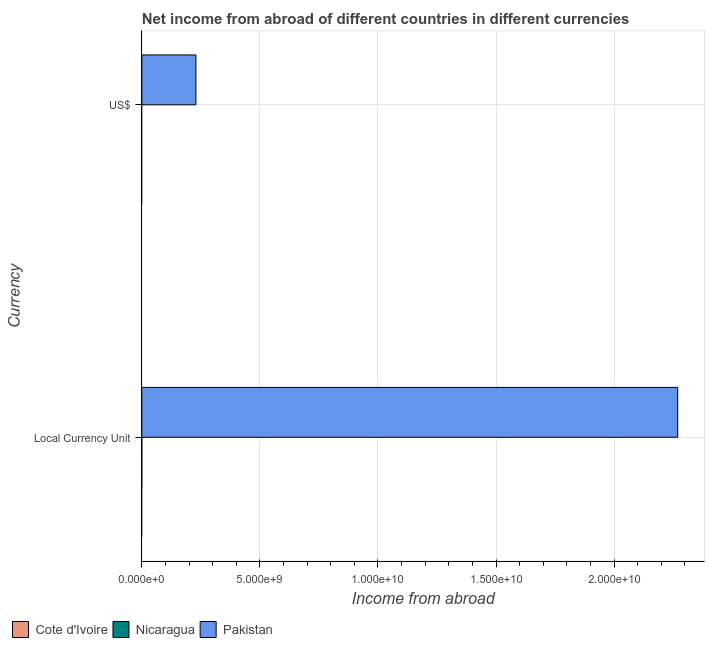Are the number of bars on each tick of the Y-axis equal?
Provide a short and direct response. Yes. How many bars are there on the 2nd tick from the top?
Ensure brevity in your answer.  1. How many bars are there on the 2nd tick from the bottom?
Provide a short and direct response. 1. What is the label of the 1st group of bars from the top?
Your response must be concise. US$. What is the income from abroad in us$ in Nicaragua?
Provide a short and direct response. 0. Across all countries, what is the maximum income from abroad in constant 2005 us$?
Provide a short and direct response. 2.27e+1. Across all countries, what is the minimum income from abroad in constant 2005 us$?
Keep it short and to the point. 0. What is the total income from abroad in us$ in the graph?
Keep it short and to the point. 2.29e+09. What is the difference between the income from abroad in us$ in Pakistan and the income from abroad in constant 2005 us$ in Cote d'Ivoire?
Your response must be concise. 2.29e+09. What is the average income from abroad in constant 2005 us$ per country?
Offer a terse response. 7.56e+09. What is the difference between the income from abroad in us$ and income from abroad in constant 2005 us$ in Pakistan?
Your answer should be compact. -2.04e+1. In how many countries, is the income from abroad in constant 2005 us$ greater than 11000000000 units?
Your response must be concise. 1. Are all the bars in the graph horizontal?
Give a very brief answer. Yes. Does the graph contain any zero values?
Offer a terse response. Yes. Does the graph contain grids?
Provide a succinct answer. Yes. How are the legend labels stacked?
Your response must be concise. Horizontal. What is the title of the graph?
Offer a terse response. Net income from abroad of different countries in different currencies. Does "Cuba" appear as one of the legend labels in the graph?
Offer a very short reply. No. What is the label or title of the X-axis?
Give a very brief answer. Income from abroad. What is the label or title of the Y-axis?
Offer a very short reply. Currency. What is the Income from abroad of Pakistan in Local Currency Unit?
Make the answer very short. 2.27e+1. What is the Income from abroad of Pakistan in US$?
Ensure brevity in your answer.  2.29e+09. Across all Currency, what is the maximum Income from abroad of Pakistan?
Offer a very short reply. 2.27e+1. Across all Currency, what is the minimum Income from abroad in Pakistan?
Keep it short and to the point. 2.29e+09. What is the total Income from abroad of Pakistan in the graph?
Your response must be concise. 2.50e+1. What is the difference between the Income from abroad in Pakistan in Local Currency Unit and that in US$?
Your answer should be compact. 2.04e+1. What is the average Income from abroad of Cote d'Ivoire per Currency?
Provide a short and direct response. 0. What is the average Income from abroad of Nicaragua per Currency?
Give a very brief answer. 0. What is the average Income from abroad in Pakistan per Currency?
Your answer should be compact. 1.25e+1. What is the ratio of the Income from abroad of Pakistan in Local Currency Unit to that in US$?
Your answer should be compact. 9.9. What is the difference between the highest and the second highest Income from abroad in Pakistan?
Ensure brevity in your answer.  2.04e+1. What is the difference between the highest and the lowest Income from abroad in Pakistan?
Your answer should be very brief. 2.04e+1. 